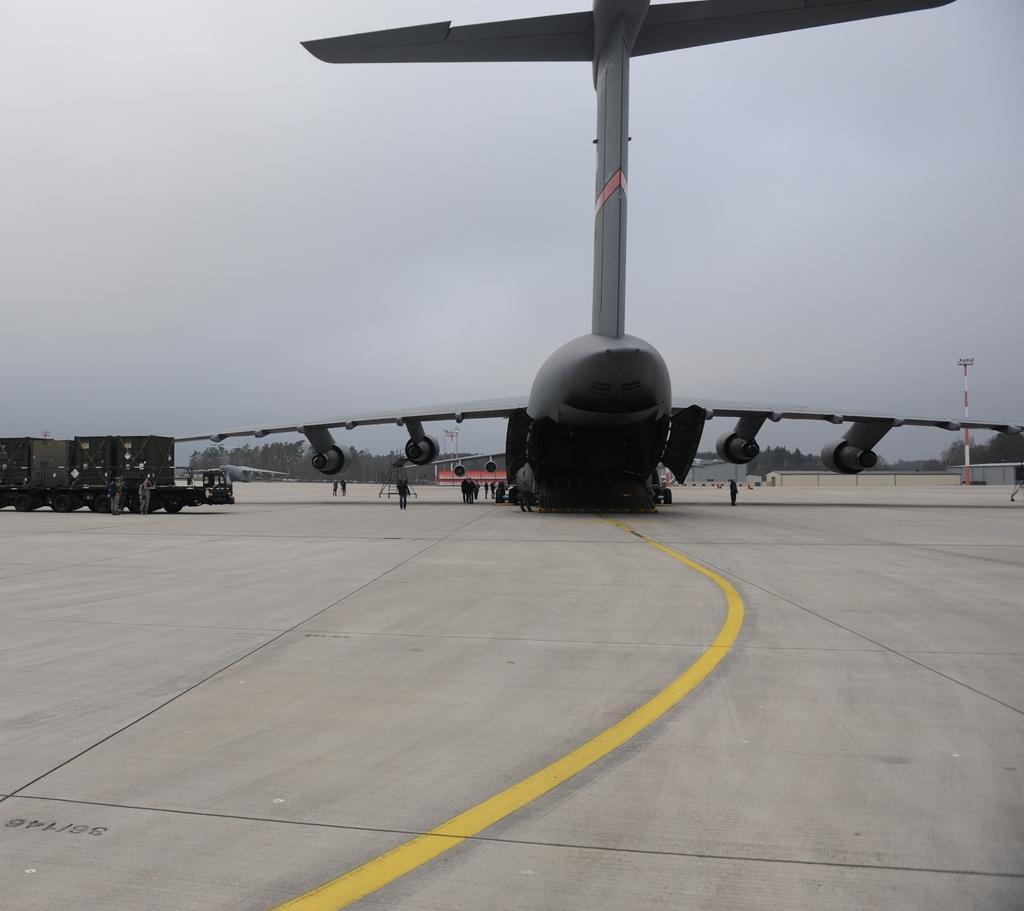In one or two sentences, can you explain what this image depicts? In the center of the image we can see aeroplane and persons on the runway. In the background we can see trees, sheds and sky. 